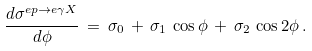<formula> <loc_0><loc_0><loc_500><loc_500>\frac { d \sigma ^ { e p \rightarrow e \gamma X } } { d \phi } \, = \, \sigma _ { 0 } \, + \, \sigma _ { 1 } \, \cos \phi \, + \, \sigma _ { 2 } \, \cos 2 \phi \, .</formula> 